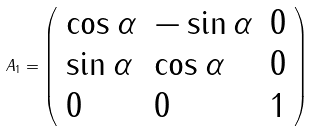<formula> <loc_0><loc_0><loc_500><loc_500>A _ { 1 } = { \left ( \begin{array} { l l l } { \cos \alpha } & { - \sin \alpha } & { 0 } \\ { \sin \alpha } & { \cos \alpha } & { 0 } \\ { 0 } & { 0 } & { 1 } \end{array} \right ) }</formula> 